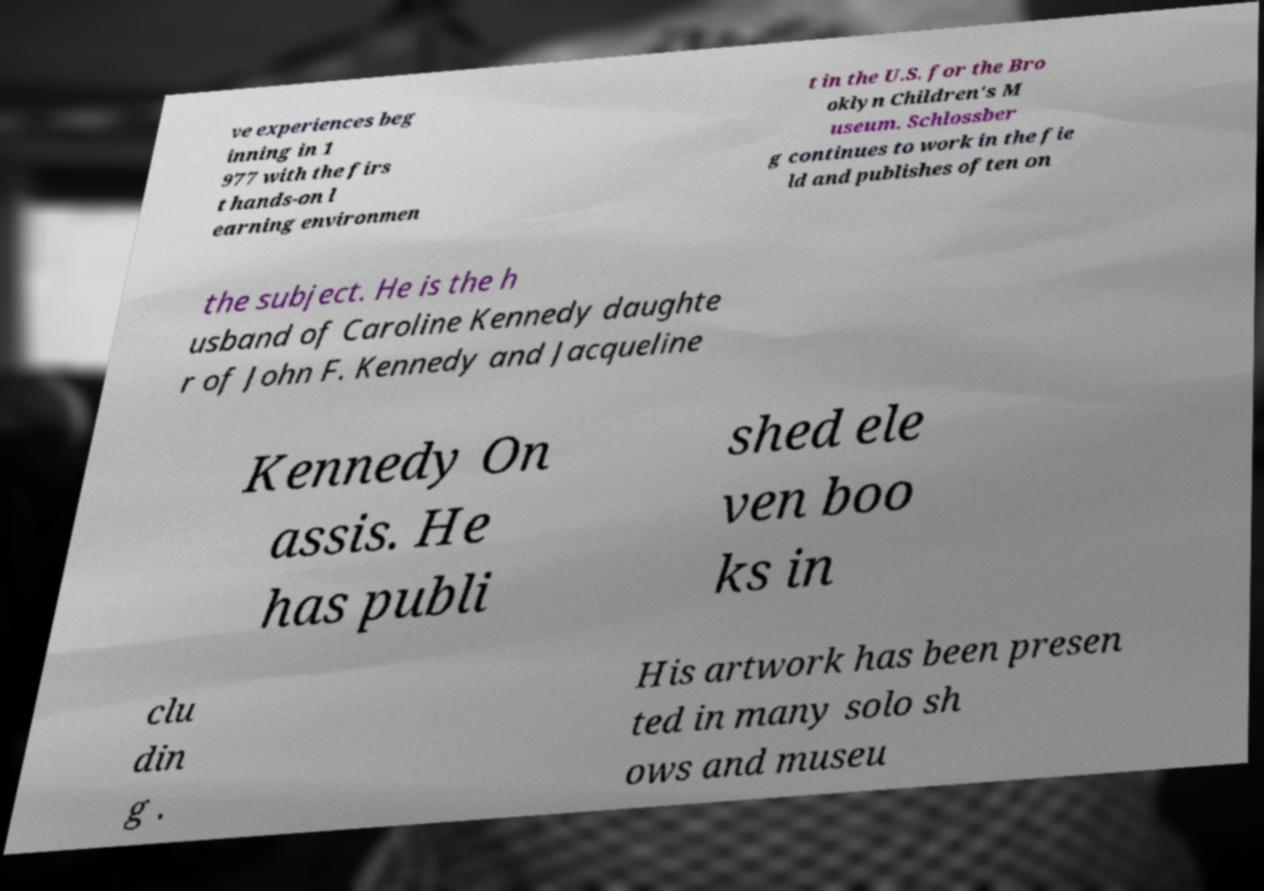Please identify and transcribe the text found in this image. ve experiences beg inning in 1 977 with the firs t hands-on l earning environmen t in the U.S. for the Bro oklyn Children's M useum. Schlossber g continues to work in the fie ld and publishes often on the subject. He is the h usband of Caroline Kennedy daughte r of John F. Kennedy and Jacqueline Kennedy On assis. He has publi shed ele ven boo ks in clu din g . His artwork has been presen ted in many solo sh ows and museu 